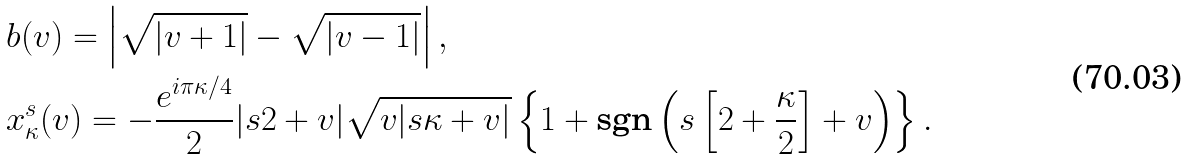<formula> <loc_0><loc_0><loc_500><loc_500>& b ( v ) = \left | \sqrt { | v + 1 | } - \sqrt { | v - 1 | } \right | , \\ & x _ { \kappa } ^ { s } ( v ) = - \frac { e ^ { i \pi \kappa / 4 } } { 2 } | s 2 + v | \sqrt { v | s \kappa + v | } \left \{ 1 + \text {sgn} \left ( s \left [ 2 + \frac { \kappa } { 2 } \right ] + v \right ) \right \} .</formula> 